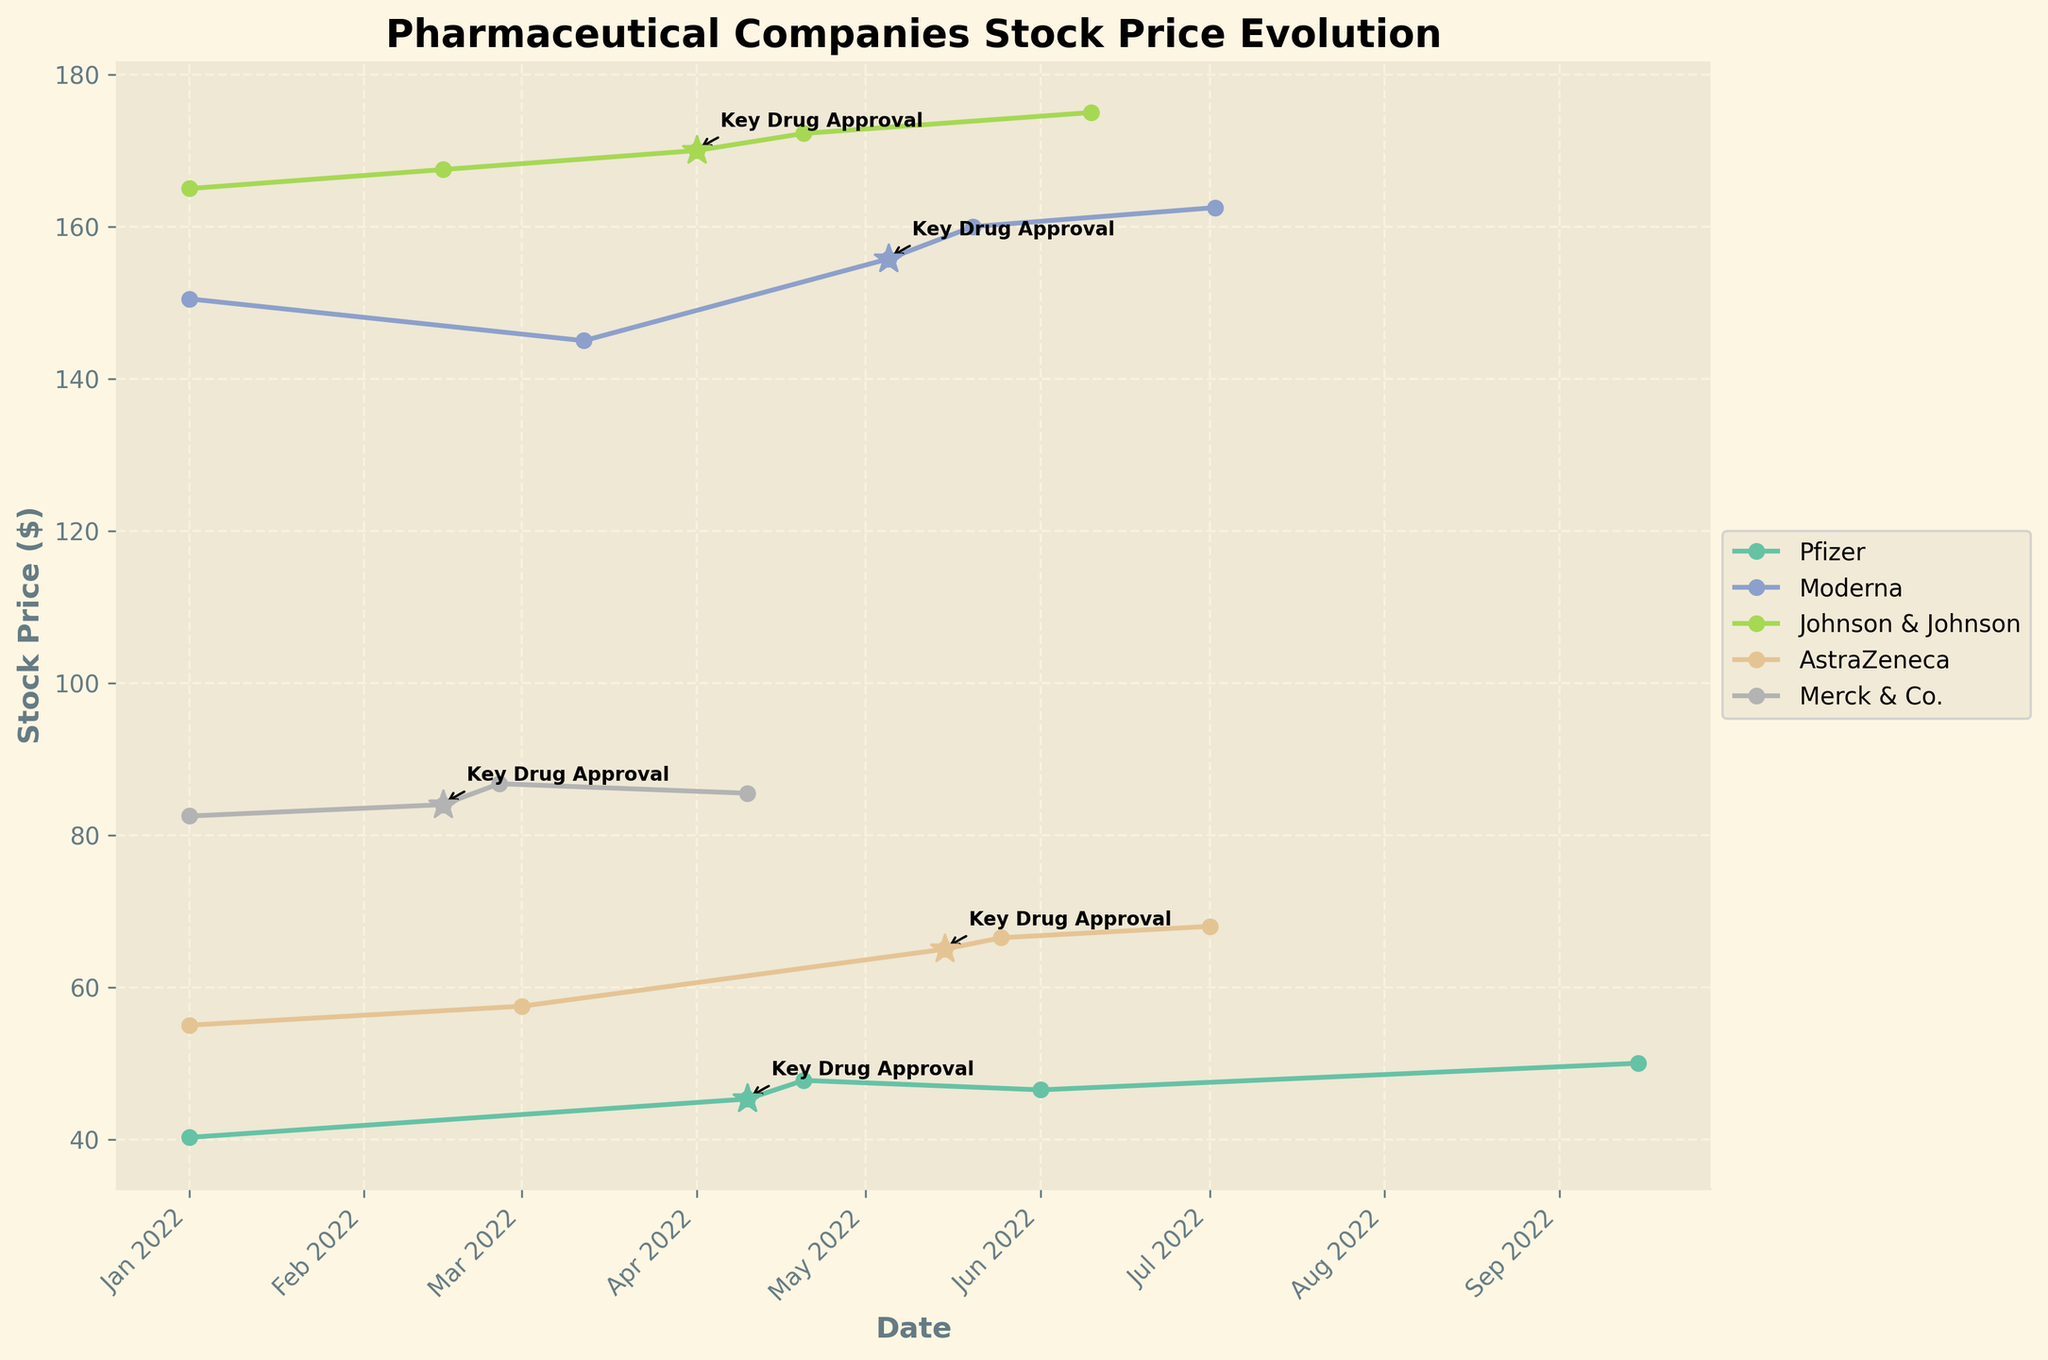What is the title of the plot? The title of the plot is written at the top and it provides an overview of the subject of the plot.
Answer: Pharmaceutical Companies' Stock Price Evolution Which company has the highest stock price at the start date? By comparing the stock prices on the earliest date in the plot, the company with the highest value can be identified. The starting dates are all January 1, 2022.
Answer: Johnson & Johnson What is the stock price of Pfizer a few days after the key drug approval? The key drug approval for Pfizer is indicated in the plot with an annotation and happens on April 10, 2022. By looking a few days after this date, we see the stock price.
Answer: $47.75 How did Moderna's stock price change right after its key drug approval? Identify the key drug approval date for Moderna, and compare the stock prices immediately before and after the event date.
Answer: Increased from $145.00 to $155.75 Which company's stock shows a steady increase after their key drug approval? By examining the trends of each company's stock prices post-approval, look for a consistent upward trend.
Answer: AstraZeneca What was the stock price of Merck & Co. on the day of its key drug approval? Locate Merck & Co.'s key drug approval annotation and note the stock price on the corresponding date.
Answer: $84.00 Between Pfizer and Johnson & Johnson, which company had a greater overall stock price increase from January to September 2022? Calculate the difference between the stock prices in January and September for both companies and compare the results. Pfizer's increase: $50.00 - $40.25 = $9.75; Johnson & Johnson's increase: $175.00 - $165.00 = $10.00.
Answer: Johnson & Johnson What can be inferred about the stock market reaction to drug approvals for these pharmaceutical companies? Analyze the stock price changes adjacent to the key drug approval markers on the plot to infer the typical market reaction, focusing on trends right before and after approvals.
Answer: Generally positive Which company's stock price remained almost stable right before and after its key drug approval? Look at the segment of each company's stock price curve immediately before and after the key drug approval annotation to find which one shows minimal change.
Answer: Merck & Co How does the stock price trend of AstraZeneca compare before and after its key drug approval? Compare the slope of the stock price curve before and after the key drug approval point, looking for relative changes. Before May 15, 2022, the price is stable, and after, it steadily increases.
Answer: Stable before, increasing after 